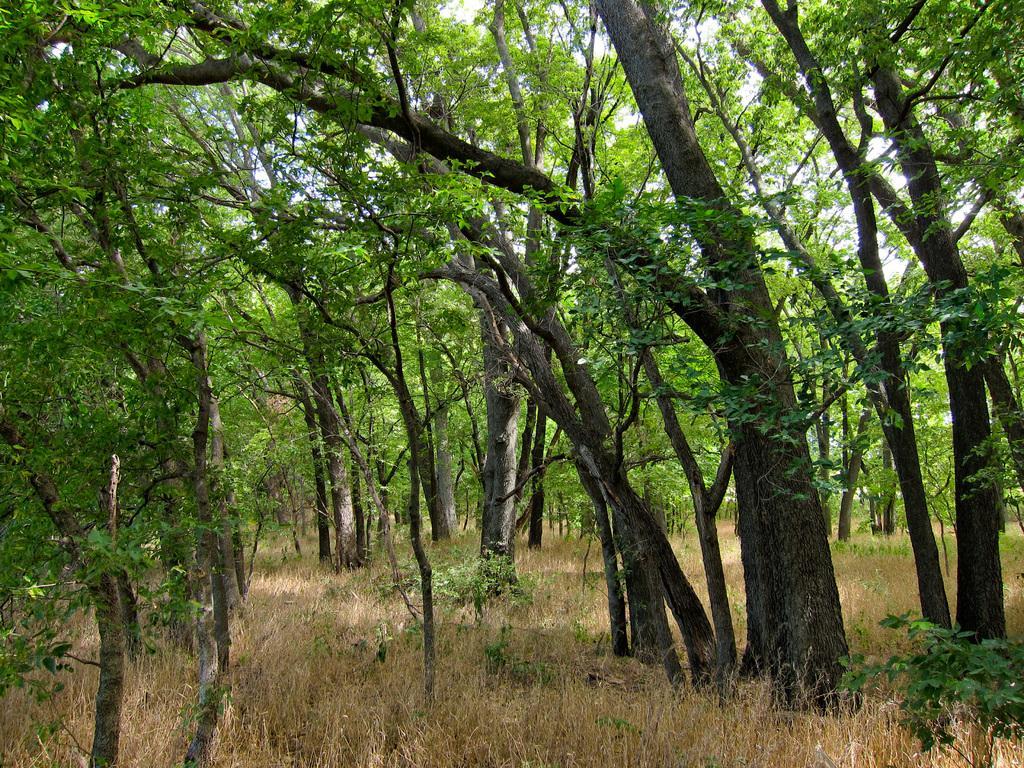Please provide a concise description of this image. This picture might be taken in a forest in this picture there are a group of trees, at the bottom there is grass and some plants. 